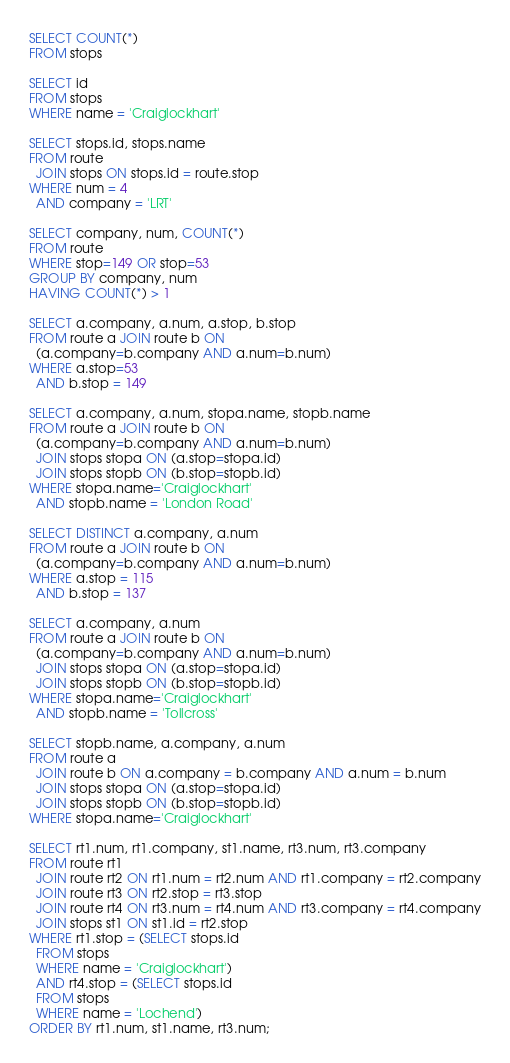<code> <loc_0><loc_0><loc_500><loc_500><_SQL_>SELECT COUNT(*)
FROM stops

SELECT id
FROM stops
WHERE name = 'Craiglockhart'

SELECT stops.id, stops.name
FROM route
  JOIN stops ON stops.id = route.stop
WHERE num = 4
  AND company = 'LRT'

SELECT company, num, COUNT(*)
FROM route
WHERE stop=149 OR stop=53
GROUP BY company, num
HAVING COUNT(*) > 1

SELECT a.company, a.num, a.stop, b.stop
FROM route a JOIN route b ON
  (a.company=b.company AND a.num=b.num)
WHERE a.stop=53
  AND b.stop = 149

SELECT a.company, a.num, stopa.name, stopb.name
FROM route a JOIN route b ON
  (a.company=b.company AND a.num=b.num)
  JOIN stops stopa ON (a.stop=stopa.id)
  JOIN stops stopb ON (b.stop=stopb.id)
WHERE stopa.name='Craiglockhart'
  AND stopb.name = 'London Road'

SELECT DISTINCT a.company, a.num
FROM route a JOIN route b ON
  (a.company=b.company AND a.num=b.num)
WHERE a.stop = 115
  AND b.stop = 137

SELECT a.company, a.num
FROM route a JOIN route b ON
  (a.company=b.company AND a.num=b.num)
  JOIN stops stopa ON (a.stop=stopa.id)
  JOIN stops stopb ON (b.stop=stopb.id)
WHERE stopa.name='Craiglockhart'
  AND stopb.name = 'Tollcross'

SELECT stopb.name, a.company, a.num
FROM route a
  JOIN route b ON a.company = b.company AND a.num = b.num
  JOIN stops stopa ON (a.stop=stopa.id)
  JOIN stops stopb ON (b.stop=stopb.id)
WHERE stopa.name='Craiglockhart'

SELECT rt1.num, rt1.company, st1.name, rt3.num, rt3.company
FROM route rt1
  JOIN route rt2 ON rt1.num = rt2.num AND rt1.company = rt2.company
  JOIN route rt3 ON rt2.stop = rt3.stop
  JOIN route rt4 ON rt3.num = rt4.num AND rt3.company = rt4.company
  JOIN stops st1 ON st1.id = rt2.stop
WHERE rt1.stop = (SELECT stops.id
  FROM stops
  WHERE name = 'Craiglockhart')
  AND rt4.stop = (SELECT stops.id
  FROM stops
  WHERE name = 'Lochend')
ORDER BY rt1.num, st1.name, rt3.num;



</code> 